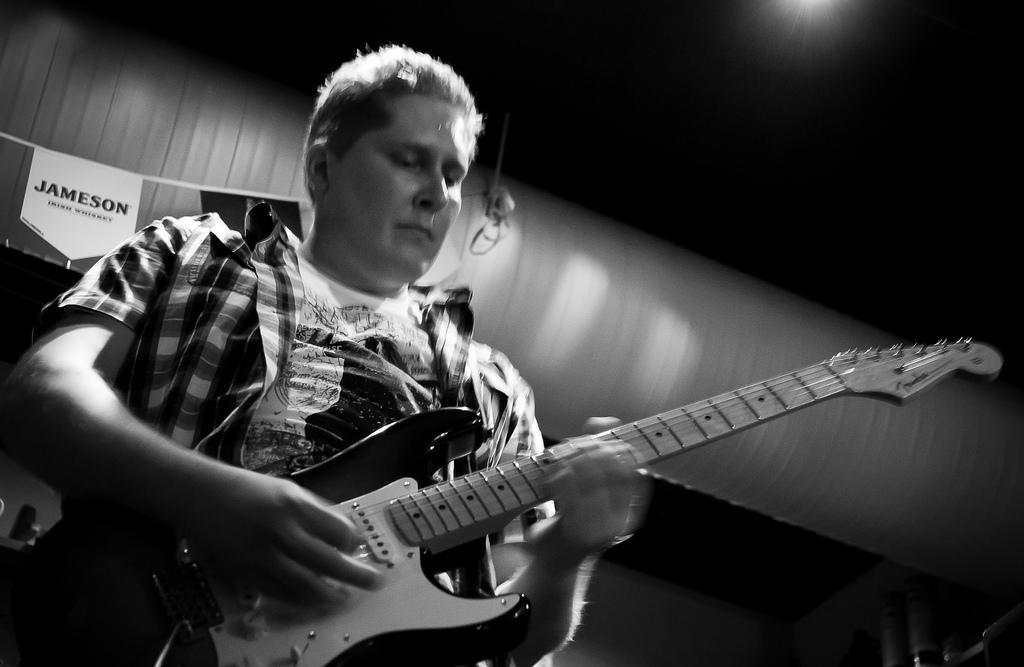Could you give a brief overview of what you see in this image? In this image I can see a man is holding a guitar. I can also see he is wearing a shirt. 